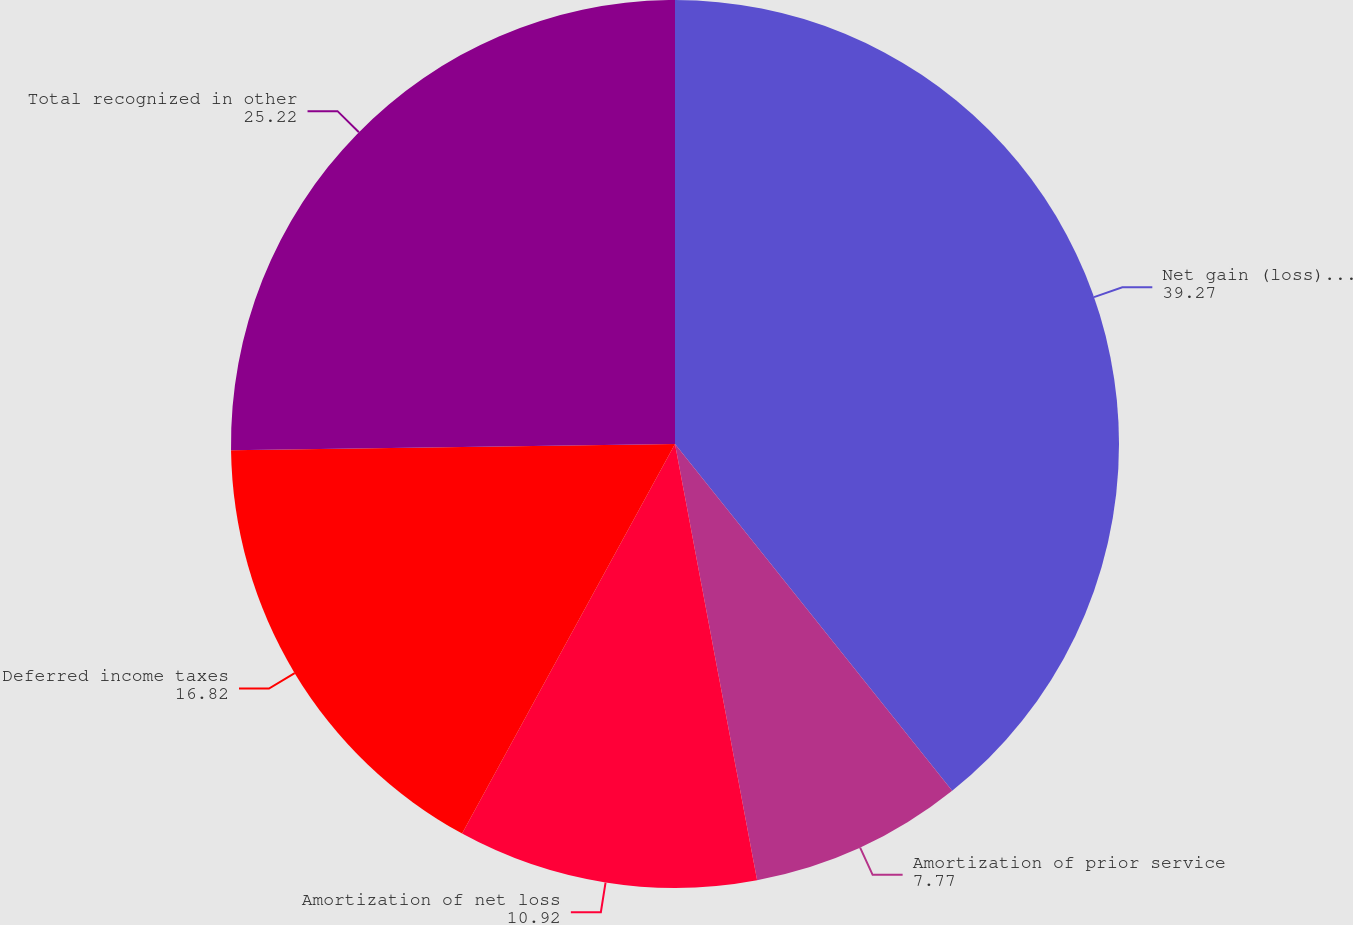<chart> <loc_0><loc_0><loc_500><loc_500><pie_chart><fcel>Net gain (loss) arising during<fcel>Amortization of prior service<fcel>Amortization of net loss<fcel>Deferred income taxes<fcel>Total recognized in other<nl><fcel>39.27%<fcel>7.77%<fcel>10.92%<fcel>16.82%<fcel>25.22%<nl></chart> 